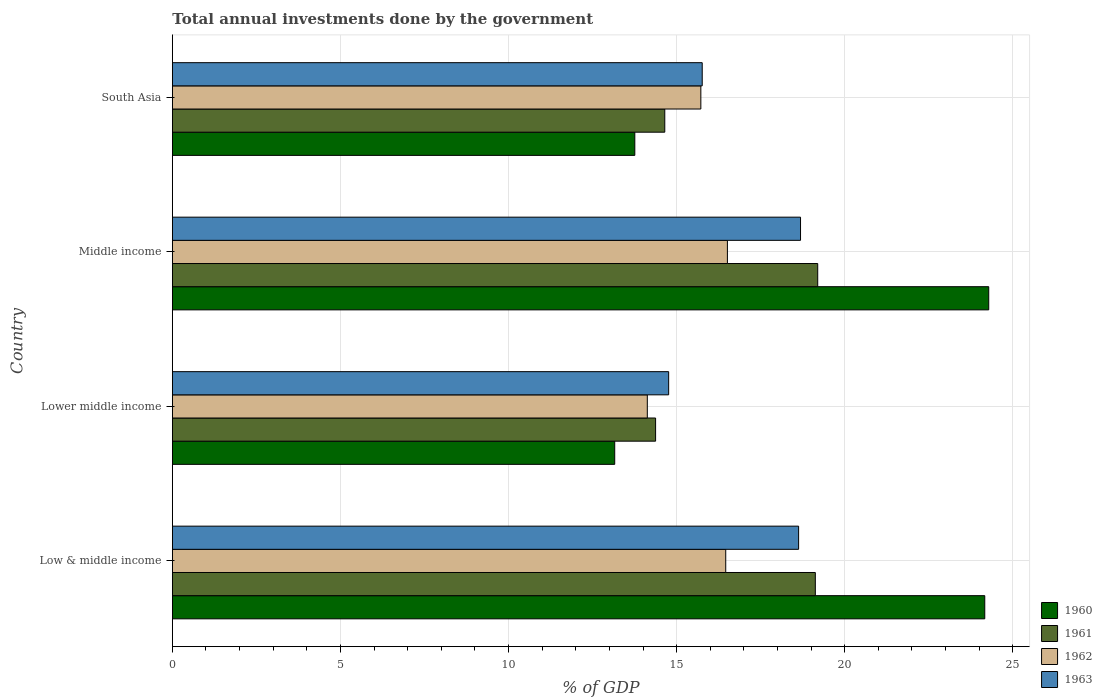How many different coloured bars are there?
Provide a succinct answer. 4. How many groups of bars are there?
Offer a very short reply. 4. Are the number of bars per tick equal to the number of legend labels?
Ensure brevity in your answer.  Yes. How many bars are there on the 2nd tick from the bottom?
Your response must be concise. 4. What is the total annual investments done by the government in 1961 in Middle income?
Ensure brevity in your answer.  19.2. Across all countries, what is the maximum total annual investments done by the government in 1962?
Your answer should be compact. 16.51. Across all countries, what is the minimum total annual investments done by the government in 1962?
Give a very brief answer. 14.13. In which country was the total annual investments done by the government in 1960 maximum?
Provide a short and direct response. Middle income. In which country was the total annual investments done by the government in 1962 minimum?
Give a very brief answer. Lower middle income. What is the total total annual investments done by the government in 1960 in the graph?
Your response must be concise. 75.37. What is the difference between the total annual investments done by the government in 1961 in Low & middle income and that in Lower middle income?
Make the answer very short. 4.75. What is the difference between the total annual investments done by the government in 1962 in South Asia and the total annual investments done by the government in 1963 in Low & middle income?
Make the answer very short. -2.91. What is the average total annual investments done by the government in 1961 per country?
Your answer should be very brief. 16.84. What is the difference between the total annual investments done by the government in 1963 and total annual investments done by the government in 1962 in Lower middle income?
Provide a succinct answer. 0.64. In how many countries, is the total annual investments done by the government in 1962 greater than 2 %?
Make the answer very short. 4. What is the ratio of the total annual investments done by the government in 1960 in Middle income to that in South Asia?
Make the answer very short. 1.77. Is the difference between the total annual investments done by the government in 1963 in Low & middle income and Middle income greater than the difference between the total annual investments done by the government in 1962 in Low & middle income and Middle income?
Offer a very short reply. No. What is the difference between the highest and the second highest total annual investments done by the government in 1963?
Provide a succinct answer. 0.06. What is the difference between the highest and the lowest total annual investments done by the government in 1962?
Ensure brevity in your answer.  2.38. Is it the case that in every country, the sum of the total annual investments done by the government in 1961 and total annual investments done by the government in 1963 is greater than the sum of total annual investments done by the government in 1960 and total annual investments done by the government in 1962?
Your response must be concise. No. Is it the case that in every country, the sum of the total annual investments done by the government in 1960 and total annual investments done by the government in 1962 is greater than the total annual investments done by the government in 1963?
Make the answer very short. Yes. How many bars are there?
Provide a succinct answer. 16. Are the values on the major ticks of X-axis written in scientific E-notation?
Your response must be concise. No. Where does the legend appear in the graph?
Ensure brevity in your answer.  Bottom right. How many legend labels are there?
Provide a succinct answer. 4. How are the legend labels stacked?
Offer a terse response. Vertical. What is the title of the graph?
Your answer should be very brief. Total annual investments done by the government. What is the label or title of the X-axis?
Offer a terse response. % of GDP. What is the label or title of the Y-axis?
Offer a very short reply. Country. What is the % of GDP of 1960 in Low & middle income?
Provide a short and direct response. 24.17. What is the % of GDP in 1961 in Low & middle income?
Provide a short and direct response. 19.13. What is the % of GDP in 1962 in Low & middle income?
Provide a short and direct response. 16.46. What is the % of GDP in 1963 in Low & middle income?
Keep it short and to the point. 18.63. What is the % of GDP of 1960 in Lower middle income?
Keep it short and to the point. 13.16. What is the % of GDP in 1961 in Lower middle income?
Provide a succinct answer. 14.37. What is the % of GDP in 1962 in Lower middle income?
Keep it short and to the point. 14.13. What is the % of GDP of 1963 in Lower middle income?
Ensure brevity in your answer.  14.76. What is the % of GDP of 1960 in Middle income?
Your answer should be very brief. 24.28. What is the % of GDP of 1961 in Middle income?
Provide a short and direct response. 19.2. What is the % of GDP in 1962 in Middle income?
Keep it short and to the point. 16.51. What is the % of GDP in 1963 in Middle income?
Offer a terse response. 18.69. What is the % of GDP of 1960 in South Asia?
Provide a short and direct response. 13.76. What is the % of GDP of 1961 in South Asia?
Your answer should be very brief. 14.65. What is the % of GDP in 1962 in South Asia?
Give a very brief answer. 15.72. What is the % of GDP of 1963 in South Asia?
Offer a terse response. 15.76. Across all countries, what is the maximum % of GDP of 1960?
Your answer should be compact. 24.28. Across all countries, what is the maximum % of GDP in 1961?
Make the answer very short. 19.2. Across all countries, what is the maximum % of GDP of 1962?
Provide a short and direct response. 16.51. Across all countries, what is the maximum % of GDP in 1963?
Your response must be concise. 18.69. Across all countries, what is the minimum % of GDP of 1960?
Offer a terse response. 13.16. Across all countries, what is the minimum % of GDP in 1961?
Your answer should be compact. 14.37. Across all countries, what is the minimum % of GDP of 1962?
Ensure brevity in your answer.  14.13. Across all countries, what is the minimum % of GDP of 1963?
Ensure brevity in your answer.  14.76. What is the total % of GDP in 1960 in the graph?
Your answer should be very brief. 75.37. What is the total % of GDP of 1961 in the graph?
Your answer should be compact. 67.35. What is the total % of GDP of 1962 in the graph?
Your response must be concise. 62.82. What is the total % of GDP in 1963 in the graph?
Your answer should be very brief. 67.84. What is the difference between the % of GDP of 1960 in Low & middle income and that in Lower middle income?
Offer a terse response. 11.01. What is the difference between the % of GDP in 1961 in Low & middle income and that in Lower middle income?
Provide a succinct answer. 4.75. What is the difference between the % of GDP in 1962 in Low & middle income and that in Lower middle income?
Provide a short and direct response. 2.33. What is the difference between the % of GDP in 1963 in Low & middle income and that in Lower middle income?
Ensure brevity in your answer.  3.87. What is the difference between the % of GDP in 1960 in Low & middle income and that in Middle income?
Your answer should be very brief. -0.12. What is the difference between the % of GDP in 1961 in Low & middle income and that in Middle income?
Keep it short and to the point. -0.07. What is the difference between the % of GDP of 1962 in Low & middle income and that in Middle income?
Keep it short and to the point. -0.05. What is the difference between the % of GDP of 1963 in Low & middle income and that in Middle income?
Provide a succinct answer. -0.06. What is the difference between the % of GDP of 1960 in Low & middle income and that in South Asia?
Provide a short and direct response. 10.41. What is the difference between the % of GDP of 1961 in Low & middle income and that in South Asia?
Your answer should be compact. 4.48. What is the difference between the % of GDP of 1962 in Low & middle income and that in South Asia?
Provide a succinct answer. 0.74. What is the difference between the % of GDP in 1963 in Low & middle income and that in South Asia?
Offer a terse response. 2.87. What is the difference between the % of GDP in 1960 in Lower middle income and that in Middle income?
Your response must be concise. -11.13. What is the difference between the % of GDP in 1961 in Lower middle income and that in Middle income?
Your answer should be very brief. -4.82. What is the difference between the % of GDP in 1962 in Lower middle income and that in Middle income?
Give a very brief answer. -2.38. What is the difference between the % of GDP in 1963 in Lower middle income and that in Middle income?
Keep it short and to the point. -3.92. What is the difference between the % of GDP in 1960 in Lower middle income and that in South Asia?
Provide a short and direct response. -0.6. What is the difference between the % of GDP in 1961 in Lower middle income and that in South Asia?
Provide a short and direct response. -0.27. What is the difference between the % of GDP of 1962 in Lower middle income and that in South Asia?
Provide a succinct answer. -1.59. What is the difference between the % of GDP of 1963 in Lower middle income and that in South Asia?
Ensure brevity in your answer.  -1. What is the difference between the % of GDP in 1960 in Middle income and that in South Asia?
Offer a terse response. 10.53. What is the difference between the % of GDP in 1961 in Middle income and that in South Asia?
Keep it short and to the point. 4.55. What is the difference between the % of GDP in 1962 in Middle income and that in South Asia?
Your response must be concise. 0.79. What is the difference between the % of GDP in 1963 in Middle income and that in South Asia?
Ensure brevity in your answer.  2.92. What is the difference between the % of GDP of 1960 in Low & middle income and the % of GDP of 1961 in Lower middle income?
Your answer should be very brief. 9.79. What is the difference between the % of GDP in 1960 in Low & middle income and the % of GDP in 1962 in Lower middle income?
Offer a terse response. 10.04. What is the difference between the % of GDP in 1960 in Low & middle income and the % of GDP in 1963 in Lower middle income?
Provide a short and direct response. 9.4. What is the difference between the % of GDP of 1961 in Low & middle income and the % of GDP of 1962 in Lower middle income?
Give a very brief answer. 5. What is the difference between the % of GDP in 1961 in Low & middle income and the % of GDP in 1963 in Lower middle income?
Offer a terse response. 4.36. What is the difference between the % of GDP in 1962 in Low & middle income and the % of GDP in 1963 in Lower middle income?
Ensure brevity in your answer.  1.7. What is the difference between the % of GDP in 1960 in Low & middle income and the % of GDP in 1961 in Middle income?
Your answer should be very brief. 4.97. What is the difference between the % of GDP in 1960 in Low & middle income and the % of GDP in 1962 in Middle income?
Offer a very short reply. 7.66. What is the difference between the % of GDP in 1960 in Low & middle income and the % of GDP in 1963 in Middle income?
Provide a succinct answer. 5.48. What is the difference between the % of GDP of 1961 in Low & middle income and the % of GDP of 1962 in Middle income?
Offer a terse response. 2.62. What is the difference between the % of GDP of 1961 in Low & middle income and the % of GDP of 1963 in Middle income?
Give a very brief answer. 0.44. What is the difference between the % of GDP in 1962 in Low & middle income and the % of GDP in 1963 in Middle income?
Provide a short and direct response. -2.22. What is the difference between the % of GDP of 1960 in Low & middle income and the % of GDP of 1961 in South Asia?
Offer a very short reply. 9.52. What is the difference between the % of GDP in 1960 in Low & middle income and the % of GDP in 1962 in South Asia?
Provide a succinct answer. 8.45. What is the difference between the % of GDP in 1960 in Low & middle income and the % of GDP in 1963 in South Asia?
Ensure brevity in your answer.  8.4. What is the difference between the % of GDP of 1961 in Low & middle income and the % of GDP of 1962 in South Asia?
Offer a terse response. 3.41. What is the difference between the % of GDP in 1961 in Low & middle income and the % of GDP in 1963 in South Asia?
Your answer should be compact. 3.36. What is the difference between the % of GDP in 1962 in Low & middle income and the % of GDP in 1963 in South Asia?
Provide a short and direct response. 0.7. What is the difference between the % of GDP in 1960 in Lower middle income and the % of GDP in 1961 in Middle income?
Ensure brevity in your answer.  -6.04. What is the difference between the % of GDP of 1960 in Lower middle income and the % of GDP of 1962 in Middle income?
Offer a very short reply. -3.35. What is the difference between the % of GDP in 1960 in Lower middle income and the % of GDP in 1963 in Middle income?
Your answer should be very brief. -5.53. What is the difference between the % of GDP of 1961 in Lower middle income and the % of GDP of 1962 in Middle income?
Provide a succinct answer. -2.14. What is the difference between the % of GDP of 1961 in Lower middle income and the % of GDP of 1963 in Middle income?
Give a very brief answer. -4.31. What is the difference between the % of GDP of 1962 in Lower middle income and the % of GDP of 1963 in Middle income?
Provide a succinct answer. -4.56. What is the difference between the % of GDP of 1960 in Lower middle income and the % of GDP of 1961 in South Asia?
Offer a very short reply. -1.49. What is the difference between the % of GDP of 1960 in Lower middle income and the % of GDP of 1962 in South Asia?
Offer a terse response. -2.56. What is the difference between the % of GDP of 1960 in Lower middle income and the % of GDP of 1963 in South Asia?
Your answer should be compact. -2.6. What is the difference between the % of GDP of 1961 in Lower middle income and the % of GDP of 1962 in South Asia?
Provide a short and direct response. -1.35. What is the difference between the % of GDP of 1961 in Lower middle income and the % of GDP of 1963 in South Asia?
Offer a terse response. -1.39. What is the difference between the % of GDP of 1962 in Lower middle income and the % of GDP of 1963 in South Asia?
Provide a short and direct response. -1.63. What is the difference between the % of GDP in 1960 in Middle income and the % of GDP in 1961 in South Asia?
Provide a short and direct response. 9.64. What is the difference between the % of GDP of 1960 in Middle income and the % of GDP of 1962 in South Asia?
Offer a very short reply. 8.56. What is the difference between the % of GDP of 1960 in Middle income and the % of GDP of 1963 in South Asia?
Give a very brief answer. 8.52. What is the difference between the % of GDP in 1961 in Middle income and the % of GDP in 1962 in South Asia?
Your answer should be compact. 3.48. What is the difference between the % of GDP of 1961 in Middle income and the % of GDP of 1963 in South Asia?
Your response must be concise. 3.44. What is the difference between the % of GDP of 1962 in Middle income and the % of GDP of 1963 in South Asia?
Keep it short and to the point. 0.75. What is the average % of GDP of 1960 per country?
Ensure brevity in your answer.  18.84. What is the average % of GDP of 1961 per country?
Give a very brief answer. 16.84. What is the average % of GDP of 1962 per country?
Your response must be concise. 15.71. What is the average % of GDP of 1963 per country?
Offer a very short reply. 16.96. What is the difference between the % of GDP in 1960 and % of GDP in 1961 in Low & middle income?
Keep it short and to the point. 5.04. What is the difference between the % of GDP in 1960 and % of GDP in 1962 in Low & middle income?
Make the answer very short. 7.71. What is the difference between the % of GDP in 1960 and % of GDP in 1963 in Low & middle income?
Provide a short and direct response. 5.54. What is the difference between the % of GDP in 1961 and % of GDP in 1962 in Low & middle income?
Offer a terse response. 2.67. What is the difference between the % of GDP of 1961 and % of GDP of 1963 in Low & middle income?
Give a very brief answer. 0.5. What is the difference between the % of GDP in 1962 and % of GDP in 1963 in Low & middle income?
Keep it short and to the point. -2.17. What is the difference between the % of GDP of 1960 and % of GDP of 1961 in Lower middle income?
Give a very brief answer. -1.22. What is the difference between the % of GDP of 1960 and % of GDP of 1962 in Lower middle income?
Give a very brief answer. -0.97. What is the difference between the % of GDP of 1960 and % of GDP of 1963 in Lower middle income?
Your answer should be compact. -1.6. What is the difference between the % of GDP of 1961 and % of GDP of 1962 in Lower middle income?
Your response must be concise. 0.25. What is the difference between the % of GDP of 1961 and % of GDP of 1963 in Lower middle income?
Provide a short and direct response. -0.39. What is the difference between the % of GDP in 1962 and % of GDP in 1963 in Lower middle income?
Provide a succinct answer. -0.64. What is the difference between the % of GDP of 1960 and % of GDP of 1961 in Middle income?
Keep it short and to the point. 5.09. What is the difference between the % of GDP of 1960 and % of GDP of 1962 in Middle income?
Ensure brevity in your answer.  7.77. What is the difference between the % of GDP in 1960 and % of GDP in 1963 in Middle income?
Offer a very short reply. 5.6. What is the difference between the % of GDP of 1961 and % of GDP of 1962 in Middle income?
Your answer should be very brief. 2.69. What is the difference between the % of GDP in 1961 and % of GDP in 1963 in Middle income?
Make the answer very short. 0.51. What is the difference between the % of GDP of 1962 and % of GDP of 1963 in Middle income?
Make the answer very short. -2.18. What is the difference between the % of GDP of 1960 and % of GDP of 1961 in South Asia?
Your answer should be very brief. -0.89. What is the difference between the % of GDP in 1960 and % of GDP in 1962 in South Asia?
Ensure brevity in your answer.  -1.96. What is the difference between the % of GDP of 1960 and % of GDP of 1963 in South Asia?
Give a very brief answer. -2.01. What is the difference between the % of GDP in 1961 and % of GDP in 1962 in South Asia?
Keep it short and to the point. -1.07. What is the difference between the % of GDP in 1961 and % of GDP in 1963 in South Asia?
Provide a succinct answer. -1.11. What is the difference between the % of GDP in 1962 and % of GDP in 1963 in South Asia?
Your answer should be compact. -0.04. What is the ratio of the % of GDP in 1960 in Low & middle income to that in Lower middle income?
Offer a very short reply. 1.84. What is the ratio of the % of GDP of 1961 in Low & middle income to that in Lower middle income?
Your answer should be compact. 1.33. What is the ratio of the % of GDP of 1962 in Low & middle income to that in Lower middle income?
Give a very brief answer. 1.17. What is the ratio of the % of GDP of 1963 in Low & middle income to that in Lower middle income?
Ensure brevity in your answer.  1.26. What is the ratio of the % of GDP in 1960 in Low & middle income to that in Middle income?
Your answer should be very brief. 1. What is the ratio of the % of GDP in 1961 in Low & middle income to that in Middle income?
Give a very brief answer. 1. What is the ratio of the % of GDP in 1963 in Low & middle income to that in Middle income?
Make the answer very short. 1. What is the ratio of the % of GDP in 1960 in Low & middle income to that in South Asia?
Your answer should be very brief. 1.76. What is the ratio of the % of GDP of 1961 in Low & middle income to that in South Asia?
Offer a terse response. 1.31. What is the ratio of the % of GDP of 1962 in Low & middle income to that in South Asia?
Provide a succinct answer. 1.05. What is the ratio of the % of GDP in 1963 in Low & middle income to that in South Asia?
Your answer should be very brief. 1.18. What is the ratio of the % of GDP in 1960 in Lower middle income to that in Middle income?
Offer a terse response. 0.54. What is the ratio of the % of GDP of 1961 in Lower middle income to that in Middle income?
Offer a very short reply. 0.75. What is the ratio of the % of GDP in 1962 in Lower middle income to that in Middle income?
Your response must be concise. 0.86. What is the ratio of the % of GDP of 1963 in Lower middle income to that in Middle income?
Your response must be concise. 0.79. What is the ratio of the % of GDP in 1960 in Lower middle income to that in South Asia?
Provide a succinct answer. 0.96. What is the ratio of the % of GDP of 1961 in Lower middle income to that in South Asia?
Ensure brevity in your answer.  0.98. What is the ratio of the % of GDP in 1962 in Lower middle income to that in South Asia?
Your response must be concise. 0.9. What is the ratio of the % of GDP of 1963 in Lower middle income to that in South Asia?
Offer a terse response. 0.94. What is the ratio of the % of GDP of 1960 in Middle income to that in South Asia?
Offer a very short reply. 1.77. What is the ratio of the % of GDP of 1961 in Middle income to that in South Asia?
Ensure brevity in your answer.  1.31. What is the ratio of the % of GDP in 1962 in Middle income to that in South Asia?
Your answer should be very brief. 1.05. What is the ratio of the % of GDP in 1963 in Middle income to that in South Asia?
Keep it short and to the point. 1.19. What is the difference between the highest and the second highest % of GDP in 1960?
Offer a very short reply. 0.12. What is the difference between the highest and the second highest % of GDP of 1961?
Provide a succinct answer. 0.07. What is the difference between the highest and the second highest % of GDP in 1962?
Offer a terse response. 0.05. What is the difference between the highest and the second highest % of GDP of 1963?
Give a very brief answer. 0.06. What is the difference between the highest and the lowest % of GDP in 1960?
Give a very brief answer. 11.13. What is the difference between the highest and the lowest % of GDP in 1961?
Your answer should be very brief. 4.82. What is the difference between the highest and the lowest % of GDP in 1962?
Give a very brief answer. 2.38. What is the difference between the highest and the lowest % of GDP of 1963?
Your response must be concise. 3.92. 